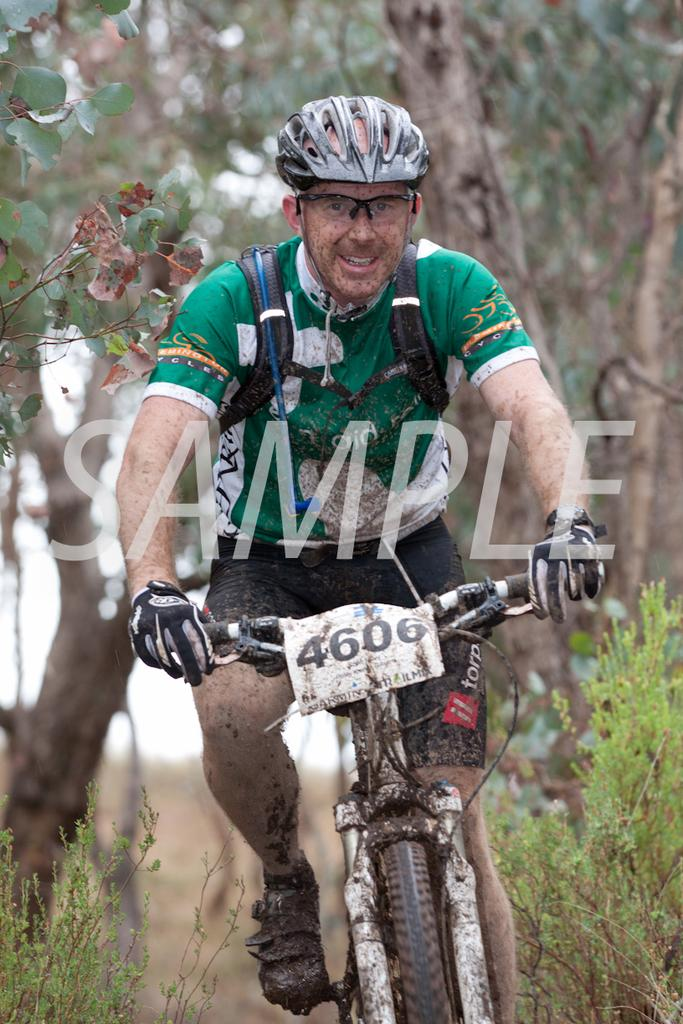What is the person in the image wearing on their head? The person is wearing a helmet in the image. What else is the person wearing to protect their eyes? The person is wearing goggles in the image. What activity is the person engaged in? The person is riding a bicycle in the image. What can be observed on the bicycle and the person's legs? There is mud attached to the bicycle and the person's legs. What type of natural environment is visible in the image? There are plants and trees in the image. What type of light is being used to illuminate the bears in the image? There are no bears present in the image, so there is no light being used to illuminate them. 